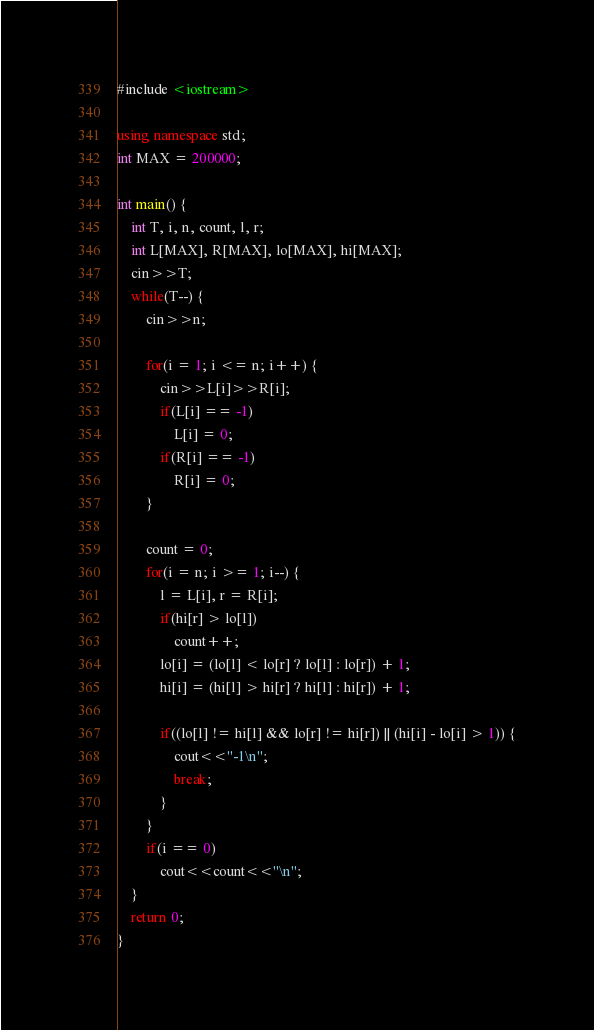<code> <loc_0><loc_0><loc_500><loc_500><_C++_>#include <iostream>

using namespace std;
int MAX = 200000;

int main() {
	int T, i, n, count, l, r;
	int L[MAX], R[MAX], lo[MAX], hi[MAX];
	cin>>T;
	while(T--) {
		cin>>n;

		for(i = 1; i <= n; i++) {
			cin>>L[i]>>R[i];
			if(L[i] == -1) 
				L[i] = 0;
			if(R[i] == -1)
				R[i] = 0;
		}

		count = 0;
		for(i = n; i >= 1; i--) {
			l = L[i], r = R[i];
			if(hi[r] > lo[l])
				count++;
			lo[i] = (lo[l] < lo[r] ? lo[l] : lo[r]) + 1;
			hi[i] = (hi[l] > hi[r] ? hi[l] : hi[r]) + 1;

			if((lo[l] != hi[l] && lo[r] != hi[r]) || (hi[i] - lo[i] > 1)) {
				cout<<"-1\n";
				break;
			}
		}
		if(i == 0)
			cout<<count<<"\n";
	}
	return 0; 
}</code> 